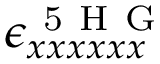Convert formula to latex. <formula><loc_0><loc_0><loc_500><loc_500>\epsilon _ { x x x x x x } ^ { 5 H G }</formula> 